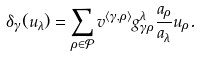Convert formula to latex. <formula><loc_0><loc_0><loc_500><loc_500>\delta _ { \gamma } ( u _ { \lambda } ) = \sum _ { \rho \in \mathcal { P } } v ^ { \langle \gamma , \rho \rangle } g _ { \gamma \rho } ^ { \lambda } \frac { a _ { \rho } } { a _ { \lambda } } u _ { \rho } .</formula> 